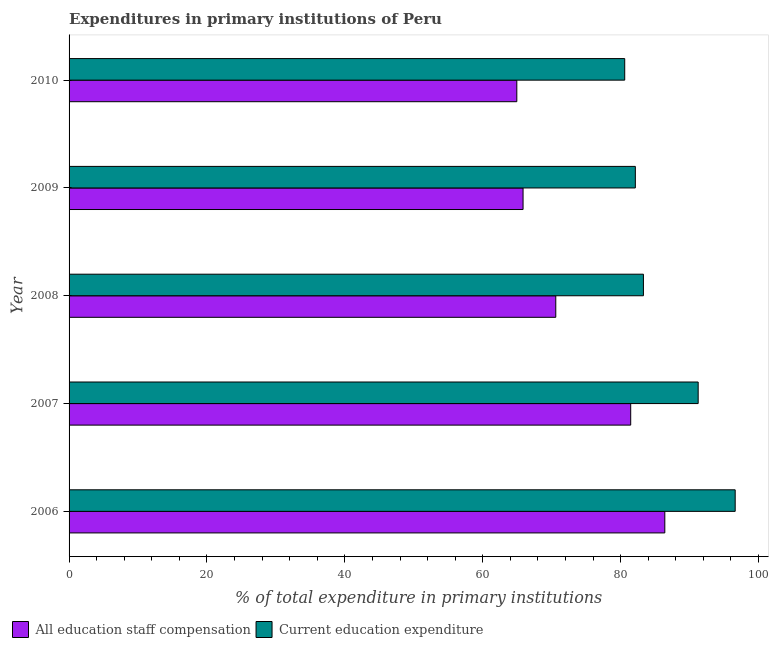Are the number of bars per tick equal to the number of legend labels?
Offer a terse response. Yes. Are the number of bars on each tick of the Y-axis equal?
Offer a very short reply. Yes. How many bars are there on the 5th tick from the top?
Provide a succinct answer. 2. How many bars are there on the 2nd tick from the bottom?
Keep it short and to the point. 2. What is the expenditure in education in 2008?
Your response must be concise. 83.3. Across all years, what is the maximum expenditure in staff compensation?
Offer a very short reply. 86.4. Across all years, what is the minimum expenditure in education?
Provide a succinct answer. 80.59. In which year was the expenditure in education maximum?
Your answer should be compact. 2006. In which year was the expenditure in education minimum?
Keep it short and to the point. 2010. What is the total expenditure in staff compensation in the graph?
Offer a very short reply. 369.23. What is the difference between the expenditure in staff compensation in 2006 and that in 2010?
Your answer should be very brief. 21.46. What is the difference between the expenditure in staff compensation in 2008 and the expenditure in education in 2006?
Give a very brief answer. -26.02. What is the average expenditure in staff compensation per year?
Provide a short and direct response. 73.85. In the year 2008, what is the difference between the expenditure in education and expenditure in staff compensation?
Your response must be concise. 12.71. In how many years, is the expenditure in staff compensation greater than 4 %?
Ensure brevity in your answer.  5. What is the ratio of the expenditure in staff compensation in 2008 to that in 2010?
Make the answer very short. 1.09. Is the expenditure in education in 2007 less than that in 2010?
Keep it short and to the point. No. Is the difference between the expenditure in staff compensation in 2006 and 2007 greater than the difference between the expenditure in education in 2006 and 2007?
Provide a short and direct response. No. What is the difference between the highest and the second highest expenditure in staff compensation?
Your answer should be compact. 4.95. What is the difference between the highest and the lowest expenditure in staff compensation?
Provide a short and direct response. 21.47. What does the 2nd bar from the top in 2007 represents?
Keep it short and to the point. All education staff compensation. What does the 2nd bar from the bottom in 2008 represents?
Provide a succinct answer. Current education expenditure. Are all the bars in the graph horizontal?
Offer a very short reply. Yes. Does the graph contain grids?
Provide a succinct answer. No. Where does the legend appear in the graph?
Make the answer very short. Bottom left. How are the legend labels stacked?
Your answer should be very brief. Horizontal. What is the title of the graph?
Your answer should be very brief. Expenditures in primary institutions of Peru. What is the label or title of the X-axis?
Keep it short and to the point. % of total expenditure in primary institutions. What is the label or title of the Y-axis?
Provide a short and direct response. Year. What is the % of total expenditure in primary institutions in All education staff compensation in 2006?
Offer a terse response. 86.4. What is the % of total expenditure in primary institutions in Current education expenditure in 2006?
Give a very brief answer. 96.61. What is the % of total expenditure in primary institutions in All education staff compensation in 2007?
Provide a succinct answer. 81.46. What is the % of total expenditure in primary institutions of Current education expenditure in 2007?
Your response must be concise. 91.24. What is the % of total expenditure in primary institutions in All education staff compensation in 2008?
Provide a short and direct response. 70.59. What is the % of total expenditure in primary institutions in Current education expenditure in 2008?
Provide a succinct answer. 83.3. What is the % of total expenditure in primary institutions in All education staff compensation in 2009?
Provide a succinct answer. 65.84. What is the % of total expenditure in primary institutions in Current education expenditure in 2009?
Your answer should be compact. 82.13. What is the % of total expenditure in primary institutions in All education staff compensation in 2010?
Your response must be concise. 64.94. What is the % of total expenditure in primary institutions of Current education expenditure in 2010?
Provide a short and direct response. 80.59. Across all years, what is the maximum % of total expenditure in primary institutions in All education staff compensation?
Make the answer very short. 86.4. Across all years, what is the maximum % of total expenditure in primary institutions of Current education expenditure?
Offer a very short reply. 96.61. Across all years, what is the minimum % of total expenditure in primary institutions in All education staff compensation?
Your answer should be very brief. 64.94. Across all years, what is the minimum % of total expenditure in primary institutions in Current education expenditure?
Your answer should be compact. 80.59. What is the total % of total expenditure in primary institutions in All education staff compensation in the graph?
Offer a terse response. 369.23. What is the total % of total expenditure in primary institutions in Current education expenditure in the graph?
Give a very brief answer. 433.87. What is the difference between the % of total expenditure in primary institutions of All education staff compensation in 2006 and that in 2007?
Make the answer very short. 4.95. What is the difference between the % of total expenditure in primary institutions of Current education expenditure in 2006 and that in 2007?
Your answer should be very brief. 5.37. What is the difference between the % of total expenditure in primary institutions of All education staff compensation in 2006 and that in 2008?
Your answer should be compact. 15.81. What is the difference between the % of total expenditure in primary institutions in Current education expenditure in 2006 and that in 2008?
Ensure brevity in your answer.  13.31. What is the difference between the % of total expenditure in primary institutions of All education staff compensation in 2006 and that in 2009?
Offer a very short reply. 20.56. What is the difference between the % of total expenditure in primary institutions in Current education expenditure in 2006 and that in 2009?
Your answer should be very brief. 14.48. What is the difference between the % of total expenditure in primary institutions of All education staff compensation in 2006 and that in 2010?
Your response must be concise. 21.47. What is the difference between the % of total expenditure in primary institutions of Current education expenditure in 2006 and that in 2010?
Provide a short and direct response. 16.02. What is the difference between the % of total expenditure in primary institutions in All education staff compensation in 2007 and that in 2008?
Provide a short and direct response. 10.87. What is the difference between the % of total expenditure in primary institutions of Current education expenditure in 2007 and that in 2008?
Provide a short and direct response. 7.94. What is the difference between the % of total expenditure in primary institutions in All education staff compensation in 2007 and that in 2009?
Your answer should be compact. 15.61. What is the difference between the % of total expenditure in primary institutions in Current education expenditure in 2007 and that in 2009?
Offer a very short reply. 9.11. What is the difference between the % of total expenditure in primary institutions of All education staff compensation in 2007 and that in 2010?
Your answer should be very brief. 16.52. What is the difference between the % of total expenditure in primary institutions of Current education expenditure in 2007 and that in 2010?
Offer a terse response. 10.65. What is the difference between the % of total expenditure in primary institutions of All education staff compensation in 2008 and that in 2009?
Your answer should be compact. 4.75. What is the difference between the % of total expenditure in primary institutions of Current education expenditure in 2008 and that in 2009?
Provide a succinct answer. 1.17. What is the difference between the % of total expenditure in primary institutions in All education staff compensation in 2008 and that in 2010?
Give a very brief answer. 5.65. What is the difference between the % of total expenditure in primary institutions of Current education expenditure in 2008 and that in 2010?
Make the answer very short. 2.71. What is the difference between the % of total expenditure in primary institutions of All education staff compensation in 2009 and that in 2010?
Offer a very short reply. 0.91. What is the difference between the % of total expenditure in primary institutions of Current education expenditure in 2009 and that in 2010?
Your answer should be very brief. 1.54. What is the difference between the % of total expenditure in primary institutions of All education staff compensation in 2006 and the % of total expenditure in primary institutions of Current education expenditure in 2007?
Provide a short and direct response. -4.84. What is the difference between the % of total expenditure in primary institutions of All education staff compensation in 2006 and the % of total expenditure in primary institutions of Current education expenditure in 2008?
Ensure brevity in your answer.  3.1. What is the difference between the % of total expenditure in primary institutions in All education staff compensation in 2006 and the % of total expenditure in primary institutions in Current education expenditure in 2009?
Your response must be concise. 4.28. What is the difference between the % of total expenditure in primary institutions of All education staff compensation in 2006 and the % of total expenditure in primary institutions of Current education expenditure in 2010?
Make the answer very short. 5.81. What is the difference between the % of total expenditure in primary institutions in All education staff compensation in 2007 and the % of total expenditure in primary institutions in Current education expenditure in 2008?
Your answer should be very brief. -1.85. What is the difference between the % of total expenditure in primary institutions of All education staff compensation in 2007 and the % of total expenditure in primary institutions of Current education expenditure in 2009?
Make the answer very short. -0.67. What is the difference between the % of total expenditure in primary institutions in All education staff compensation in 2007 and the % of total expenditure in primary institutions in Current education expenditure in 2010?
Keep it short and to the point. 0.87. What is the difference between the % of total expenditure in primary institutions in All education staff compensation in 2008 and the % of total expenditure in primary institutions in Current education expenditure in 2009?
Your response must be concise. -11.54. What is the difference between the % of total expenditure in primary institutions of All education staff compensation in 2008 and the % of total expenditure in primary institutions of Current education expenditure in 2010?
Give a very brief answer. -10. What is the difference between the % of total expenditure in primary institutions of All education staff compensation in 2009 and the % of total expenditure in primary institutions of Current education expenditure in 2010?
Provide a short and direct response. -14.75. What is the average % of total expenditure in primary institutions of All education staff compensation per year?
Give a very brief answer. 73.85. What is the average % of total expenditure in primary institutions in Current education expenditure per year?
Make the answer very short. 86.77. In the year 2006, what is the difference between the % of total expenditure in primary institutions of All education staff compensation and % of total expenditure in primary institutions of Current education expenditure?
Provide a short and direct response. -10.21. In the year 2007, what is the difference between the % of total expenditure in primary institutions in All education staff compensation and % of total expenditure in primary institutions in Current education expenditure?
Offer a very short reply. -9.79. In the year 2008, what is the difference between the % of total expenditure in primary institutions of All education staff compensation and % of total expenditure in primary institutions of Current education expenditure?
Give a very brief answer. -12.71. In the year 2009, what is the difference between the % of total expenditure in primary institutions of All education staff compensation and % of total expenditure in primary institutions of Current education expenditure?
Make the answer very short. -16.28. In the year 2010, what is the difference between the % of total expenditure in primary institutions of All education staff compensation and % of total expenditure in primary institutions of Current education expenditure?
Your answer should be compact. -15.65. What is the ratio of the % of total expenditure in primary institutions of All education staff compensation in 2006 to that in 2007?
Give a very brief answer. 1.06. What is the ratio of the % of total expenditure in primary institutions in Current education expenditure in 2006 to that in 2007?
Make the answer very short. 1.06. What is the ratio of the % of total expenditure in primary institutions of All education staff compensation in 2006 to that in 2008?
Keep it short and to the point. 1.22. What is the ratio of the % of total expenditure in primary institutions of Current education expenditure in 2006 to that in 2008?
Provide a succinct answer. 1.16. What is the ratio of the % of total expenditure in primary institutions of All education staff compensation in 2006 to that in 2009?
Offer a very short reply. 1.31. What is the ratio of the % of total expenditure in primary institutions in Current education expenditure in 2006 to that in 2009?
Your answer should be compact. 1.18. What is the ratio of the % of total expenditure in primary institutions of All education staff compensation in 2006 to that in 2010?
Make the answer very short. 1.33. What is the ratio of the % of total expenditure in primary institutions in Current education expenditure in 2006 to that in 2010?
Offer a terse response. 1.2. What is the ratio of the % of total expenditure in primary institutions of All education staff compensation in 2007 to that in 2008?
Your answer should be very brief. 1.15. What is the ratio of the % of total expenditure in primary institutions of Current education expenditure in 2007 to that in 2008?
Offer a terse response. 1.1. What is the ratio of the % of total expenditure in primary institutions in All education staff compensation in 2007 to that in 2009?
Provide a short and direct response. 1.24. What is the ratio of the % of total expenditure in primary institutions of Current education expenditure in 2007 to that in 2009?
Offer a terse response. 1.11. What is the ratio of the % of total expenditure in primary institutions in All education staff compensation in 2007 to that in 2010?
Your answer should be very brief. 1.25. What is the ratio of the % of total expenditure in primary institutions of Current education expenditure in 2007 to that in 2010?
Offer a very short reply. 1.13. What is the ratio of the % of total expenditure in primary institutions of All education staff compensation in 2008 to that in 2009?
Give a very brief answer. 1.07. What is the ratio of the % of total expenditure in primary institutions in Current education expenditure in 2008 to that in 2009?
Make the answer very short. 1.01. What is the ratio of the % of total expenditure in primary institutions of All education staff compensation in 2008 to that in 2010?
Your answer should be very brief. 1.09. What is the ratio of the % of total expenditure in primary institutions of Current education expenditure in 2008 to that in 2010?
Offer a terse response. 1.03. What is the ratio of the % of total expenditure in primary institutions of All education staff compensation in 2009 to that in 2010?
Your answer should be compact. 1.01. What is the ratio of the % of total expenditure in primary institutions of Current education expenditure in 2009 to that in 2010?
Provide a short and direct response. 1.02. What is the difference between the highest and the second highest % of total expenditure in primary institutions in All education staff compensation?
Provide a succinct answer. 4.95. What is the difference between the highest and the second highest % of total expenditure in primary institutions of Current education expenditure?
Your answer should be very brief. 5.37. What is the difference between the highest and the lowest % of total expenditure in primary institutions of All education staff compensation?
Offer a very short reply. 21.47. What is the difference between the highest and the lowest % of total expenditure in primary institutions of Current education expenditure?
Provide a short and direct response. 16.02. 